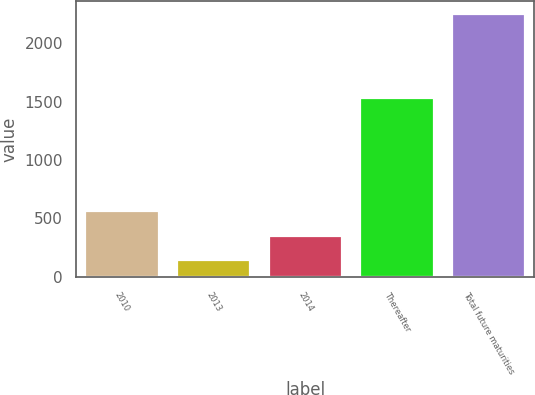Convert chart. <chart><loc_0><loc_0><loc_500><loc_500><bar_chart><fcel>2010<fcel>2013<fcel>2014<fcel>Thereafter<fcel>Total future maturities<nl><fcel>563.4<fcel>142<fcel>352.7<fcel>1528<fcel>2249<nl></chart> 